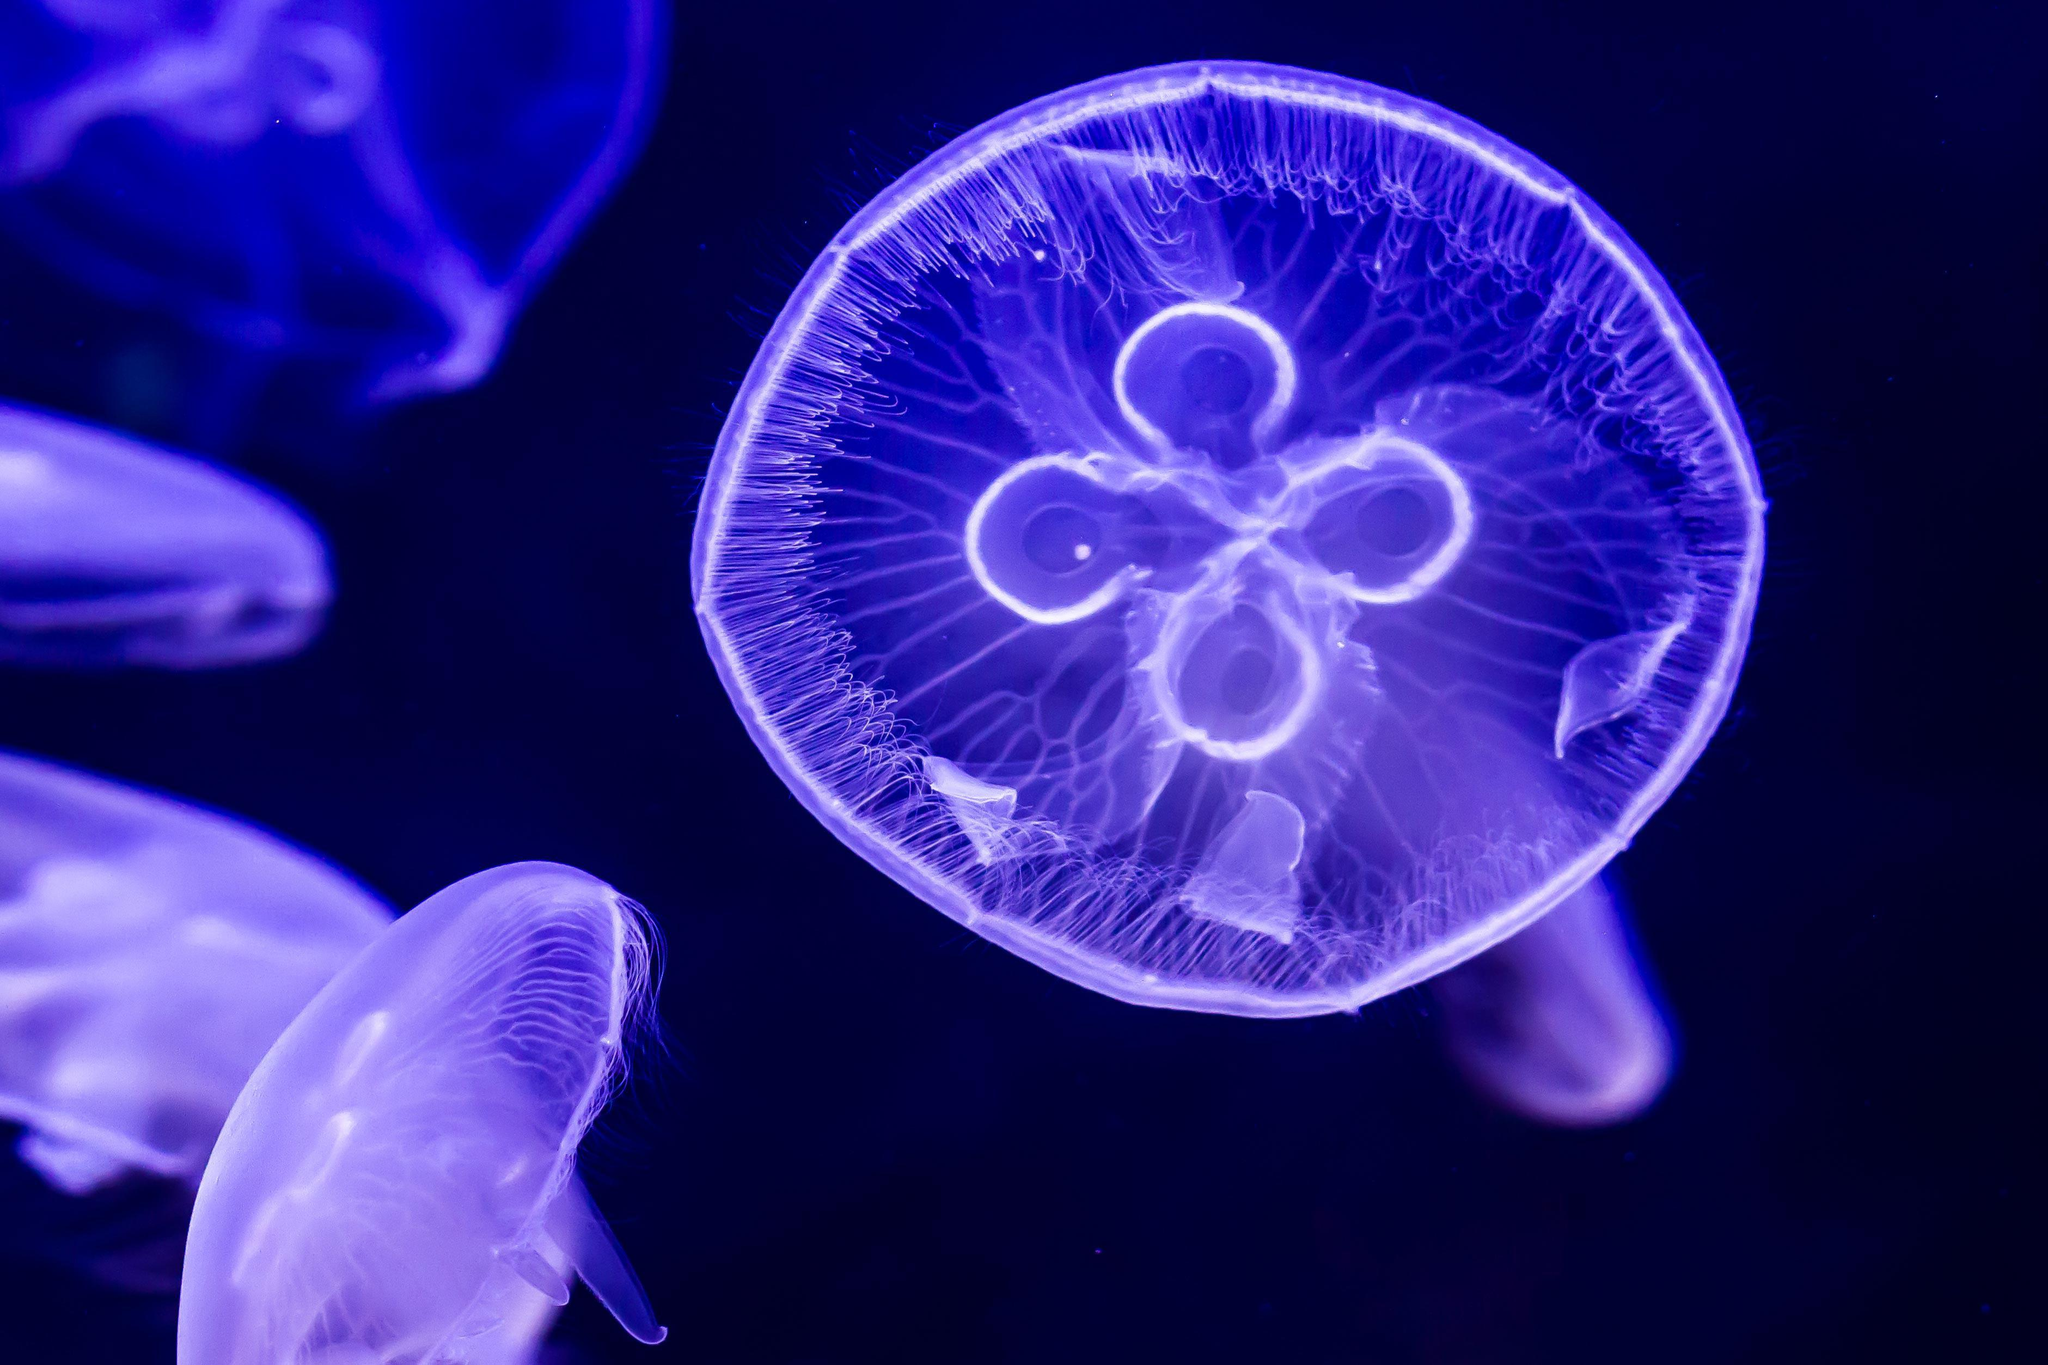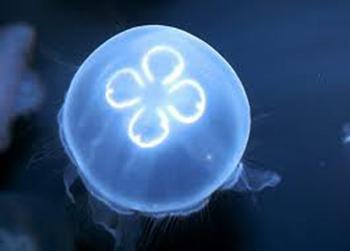The first image is the image on the left, the second image is the image on the right. Given the left and right images, does the statement "At least one of the images has a purple tint to it; not just blue with tinges of orange." hold true? Answer yes or no. Yes. The first image is the image on the left, the second image is the image on the right. For the images shown, is this caption "Each image includes one jellyfish viewed with its """"cap"""" head-on, showing something that resembles a neon-lit four-leaf clover." true? Answer yes or no. Yes. 